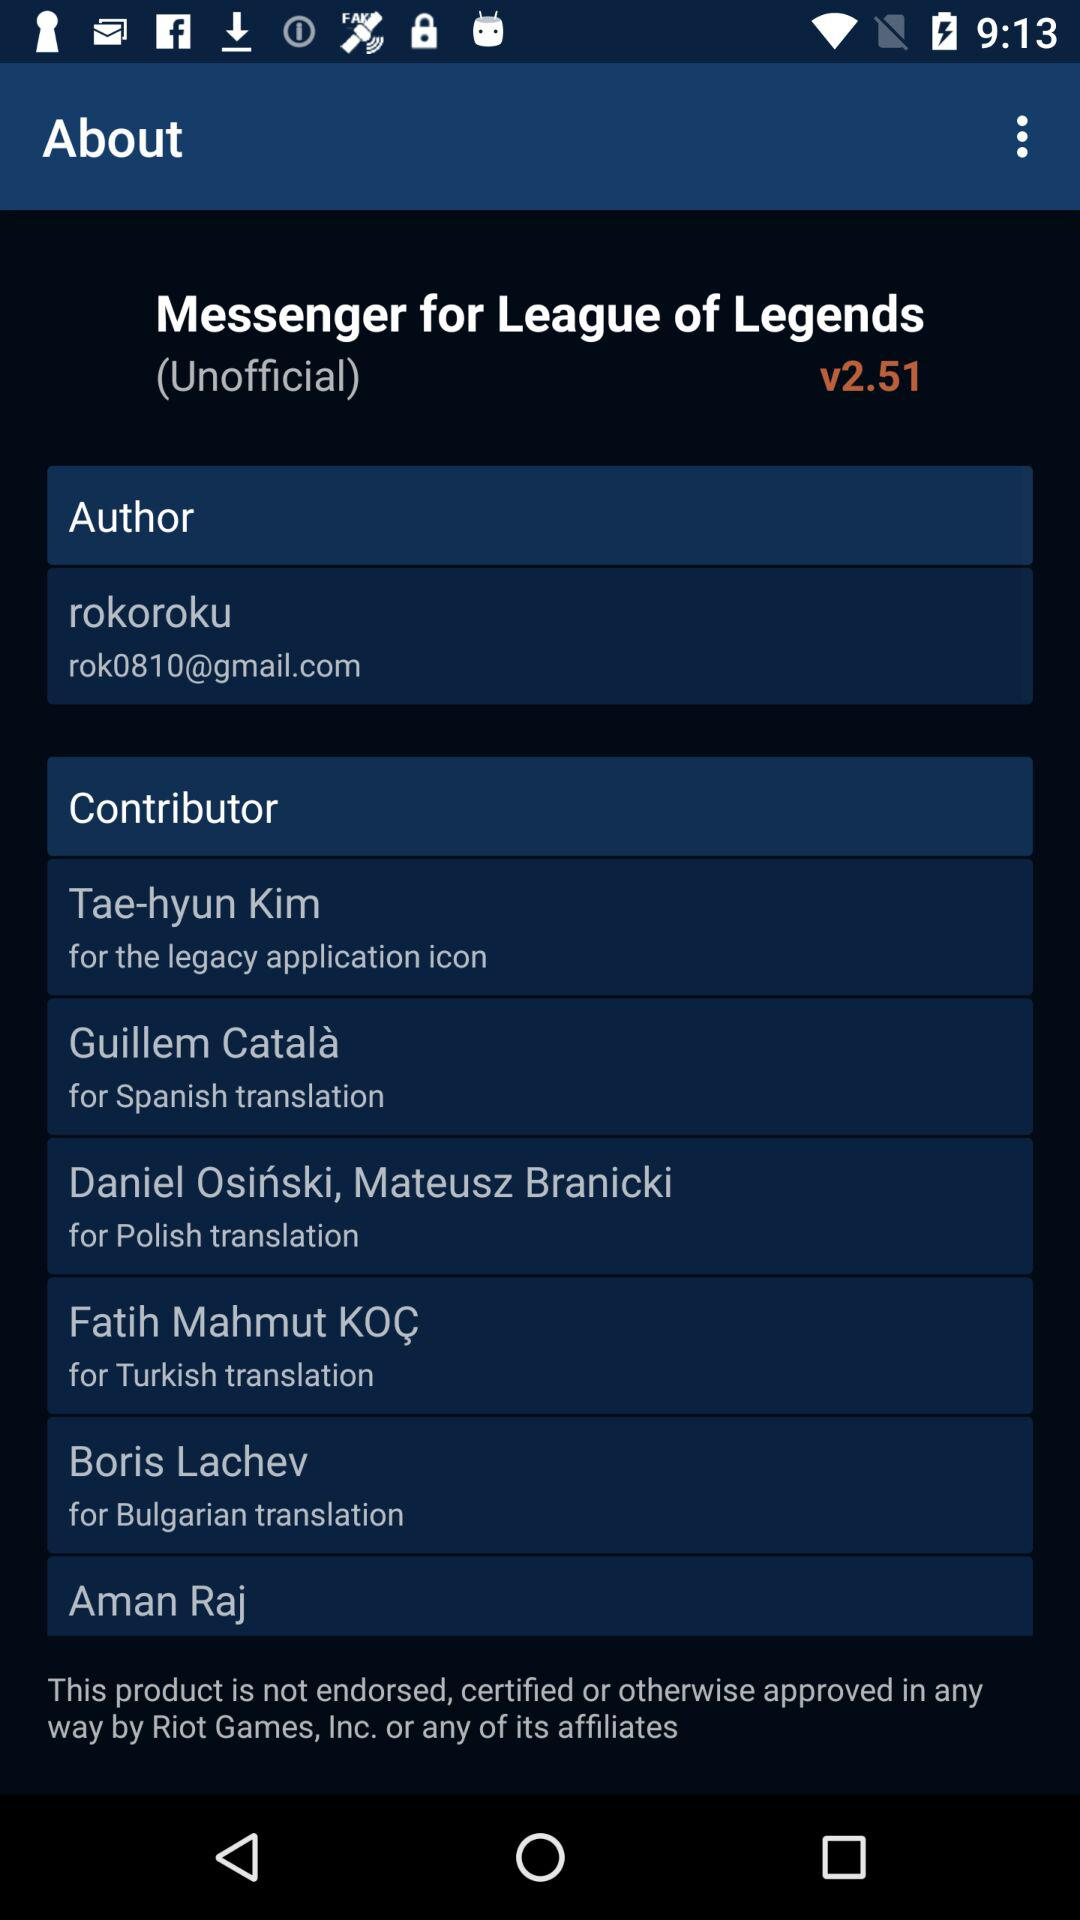How many versions of the app have been released?
Answer the question using a single word or phrase. 2.51 